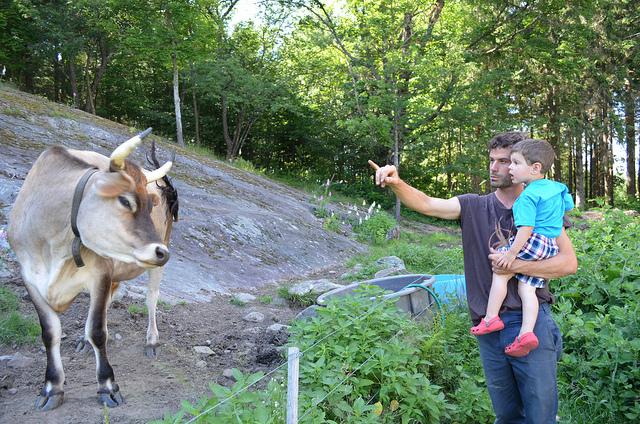Is the child's mouth open or closed?
Quick response, please. Open. What is on the ground?
Write a very short answer. Dirt. What color are the bull's shins?
Concise answer only. Black. Which finger is pointing?
Quick response, please. Pinky. 